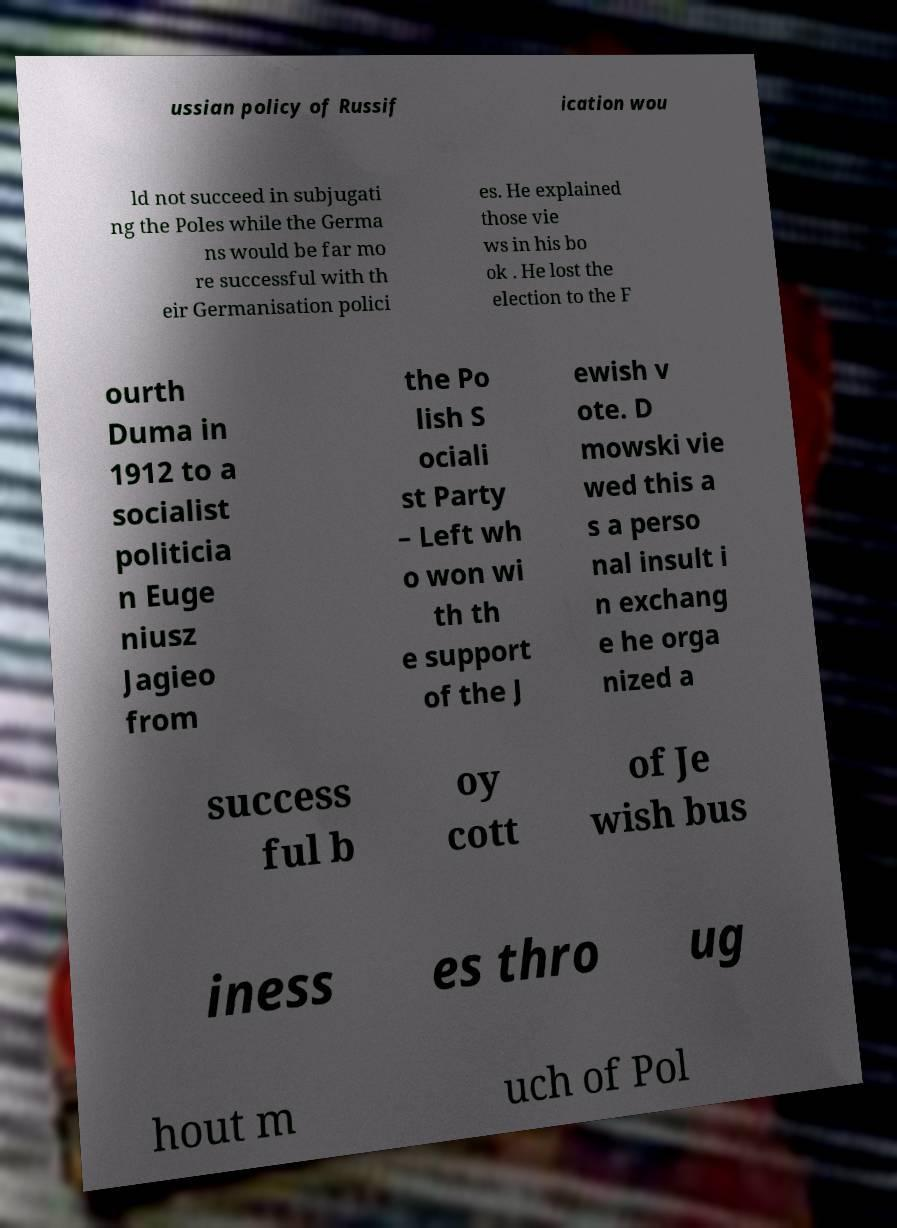Please identify and transcribe the text found in this image. ussian policy of Russif ication wou ld not succeed in subjugati ng the Poles while the Germa ns would be far mo re successful with th eir Germanisation polici es. He explained those vie ws in his bo ok . He lost the election to the F ourth Duma in 1912 to a socialist politicia n Euge niusz Jagieo from the Po lish S ociali st Party – Left wh o won wi th th e support of the J ewish v ote. D mowski vie wed this a s a perso nal insult i n exchang e he orga nized a success ful b oy cott of Je wish bus iness es thro ug hout m uch of Pol 